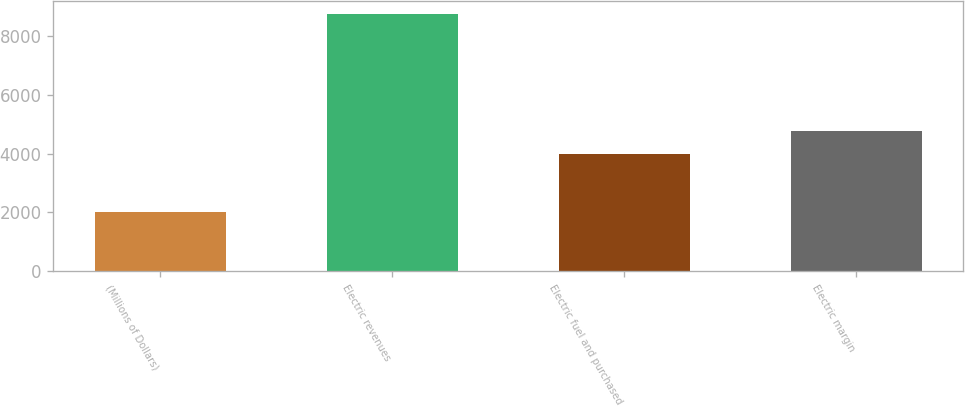Convert chart. <chart><loc_0><loc_0><loc_500><loc_500><bar_chart><fcel>(Millions of Dollars)<fcel>Electric revenues<fcel>Electric fuel and purchased<fcel>Electric margin<nl><fcel>2011<fcel>8767<fcel>3992<fcel>4775<nl></chart> 